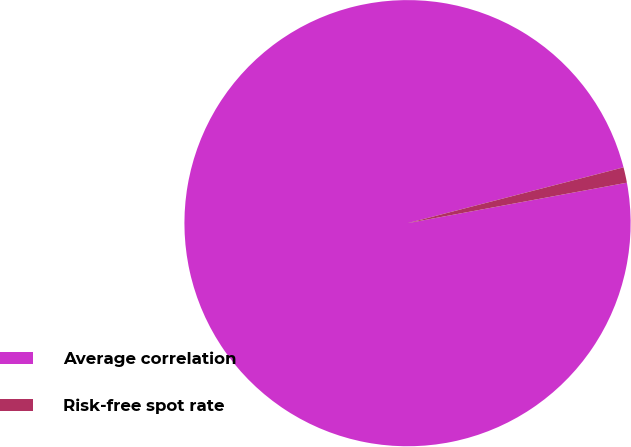Convert chart to OTSL. <chart><loc_0><loc_0><loc_500><loc_500><pie_chart><fcel>Average correlation<fcel>Risk-free spot rate<nl><fcel>98.88%<fcel>1.12%<nl></chart> 